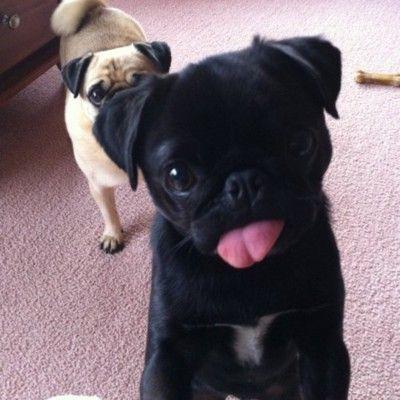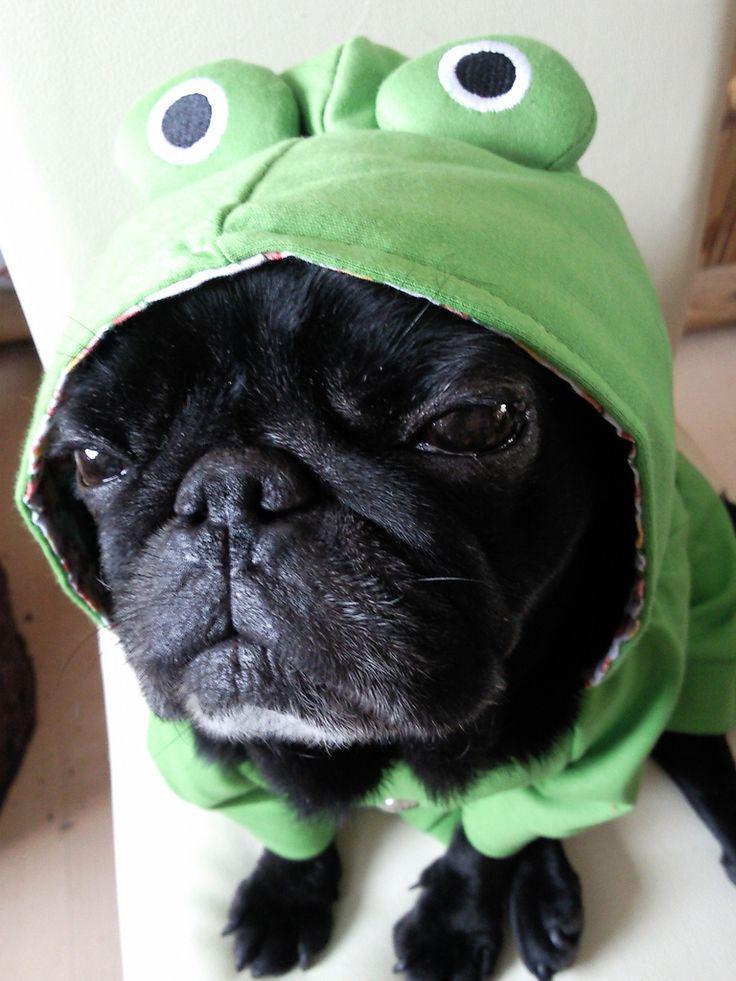The first image is the image on the left, the second image is the image on the right. Assess this claim about the two images: "There are at least four pugs.". Correct or not? Answer yes or no. No. The first image is the image on the left, the second image is the image on the right. Given the left and right images, does the statement "All dogs are in soft-sided containers, and all dogs are light tan with dark faces." hold true? Answer yes or no. No. 